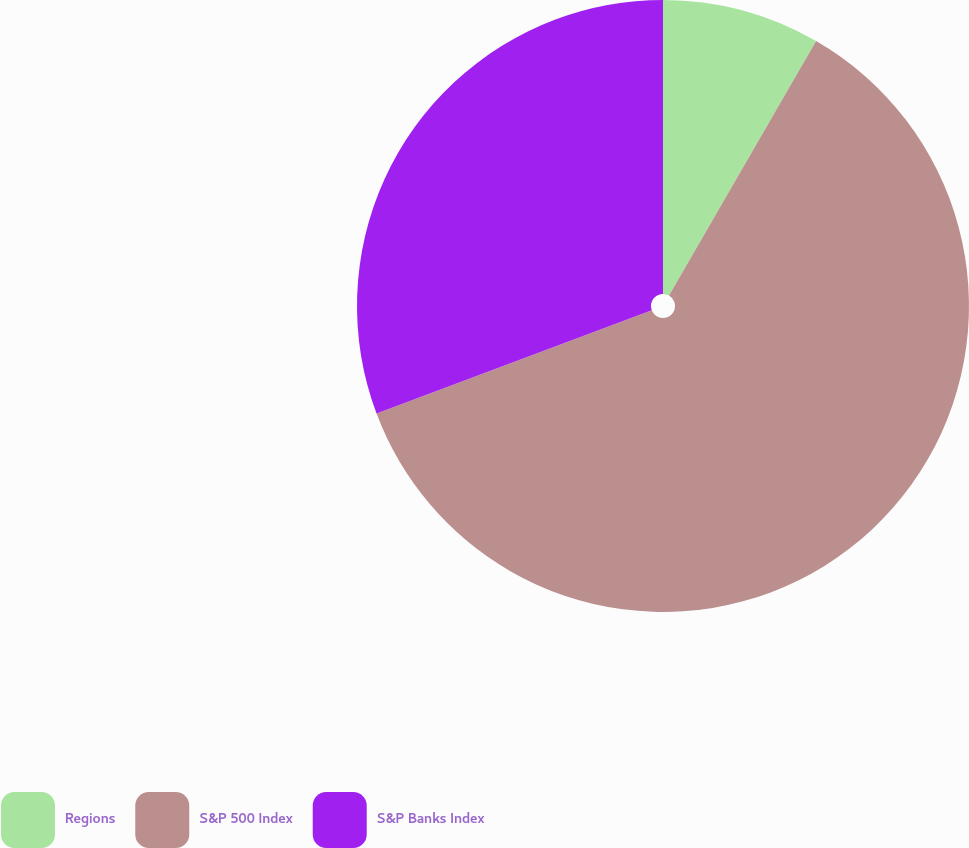<chart> <loc_0><loc_0><loc_500><loc_500><pie_chart><fcel>Regions<fcel>S&P 500 Index<fcel>S&P Banks Index<nl><fcel>8.34%<fcel>60.94%<fcel>30.72%<nl></chart> 